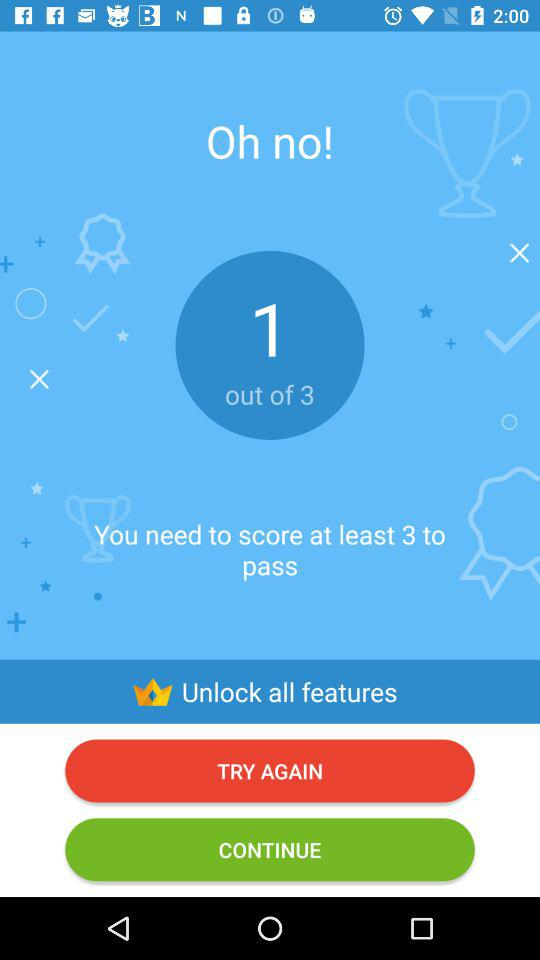What is the lowest score to pass? You need to score at least 3 to pass. 